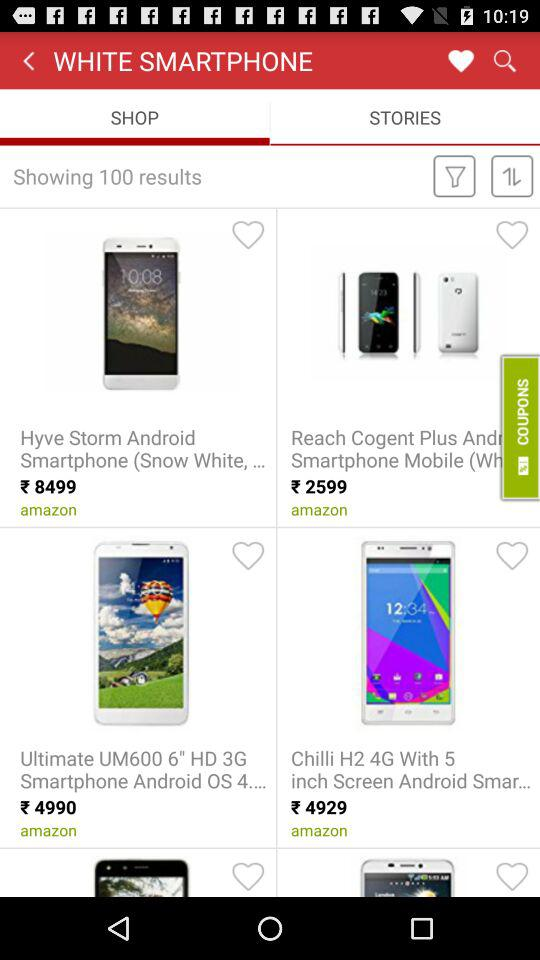How many results are shown? There are 100 results shown on the screen. 